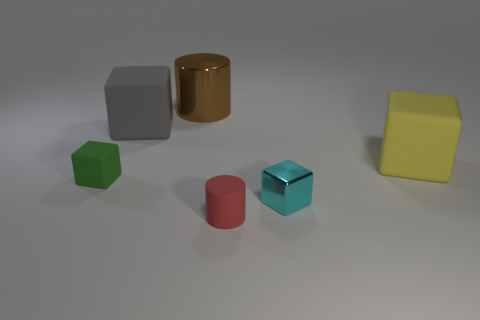Add 1 tiny cyan cubes. How many objects exist? 7 Subtract all yellow cubes. How many cubes are left? 3 Subtract all gray matte blocks. How many blocks are left? 3 Subtract all cylinders. How many objects are left? 4 Subtract 2 cylinders. How many cylinders are left? 0 Add 4 large gray blocks. How many large gray blocks are left? 5 Add 6 big gray rubber spheres. How many big gray rubber spheres exist? 6 Subtract 0 cyan cylinders. How many objects are left? 6 Subtract all cyan cylinders. Subtract all red cubes. How many cylinders are left? 2 Subtract all yellow cubes. How many blue cylinders are left? 0 